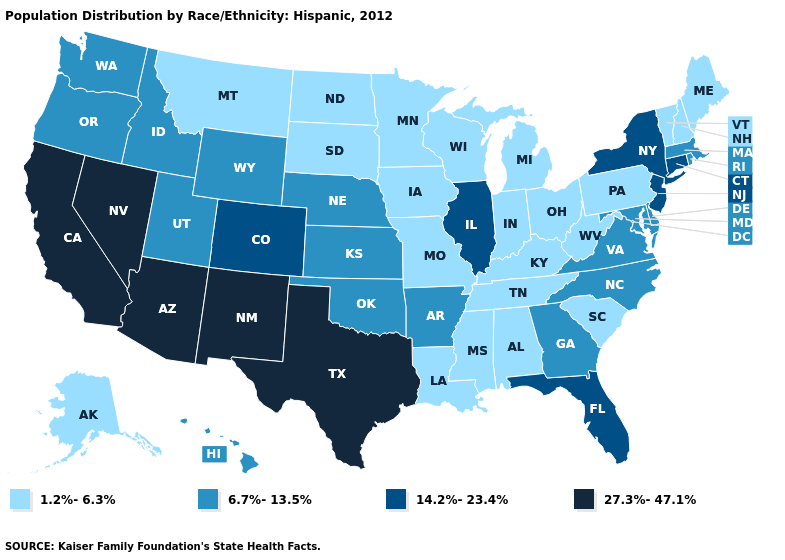Does Alaska have a lower value than Michigan?
Concise answer only. No. Name the states that have a value in the range 6.7%-13.5%?
Quick response, please. Arkansas, Delaware, Georgia, Hawaii, Idaho, Kansas, Maryland, Massachusetts, Nebraska, North Carolina, Oklahoma, Oregon, Rhode Island, Utah, Virginia, Washington, Wyoming. Among the states that border Oregon , does Nevada have the highest value?
Quick response, please. Yes. Which states have the highest value in the USA?
Keep it brief. Arizona, California, Nevada, New Mexico, Texas. Does Iowa have the highest value in the MidWest?
Quick response, please. No. What is the lowest value in the MidWest?
Give a very brief answer. 1.2%-6.3%. Does the map have missing data?
Quick response, please. No. How many symbols are there in the legend?
Quick response, please. 4. Is the legend a continuous bar?
Keep it brief. No. Does Pennsylvania have the highest value in the Northeast?
Write a very short answer. No. Which states have the lowest value in the USA?
Short answer required. Alabama, Alaska, Indiana, Iowa, Kentucky, Louisiana, Maine, Michigan, Minnesota, Mississippi, Missouri, Montana, New Hampshire, North Dakota, Ohio, Pennsylvania, South Carolina, South Dakota, Tennessee, Vermont, West Virginia, Wisconsin. Name the states that have a value in the range 27.3%-47.1%?
Answer briefly. Arizona, California, Nevada, New Mexico, Texas. Name the states that have a value in the range 27.3%-47.1%?
Quick response, please. Arizona, California, Nevada, New Mexico, Texas. Does Illinois have the lowest value in the MidWest?
Keep it brief. No. Which states have the lowest value in the South?
Be succinct. Alabama, Kentucky, Louisiana, Mississippi, South Carolina, Tennessee, West Virginia. 